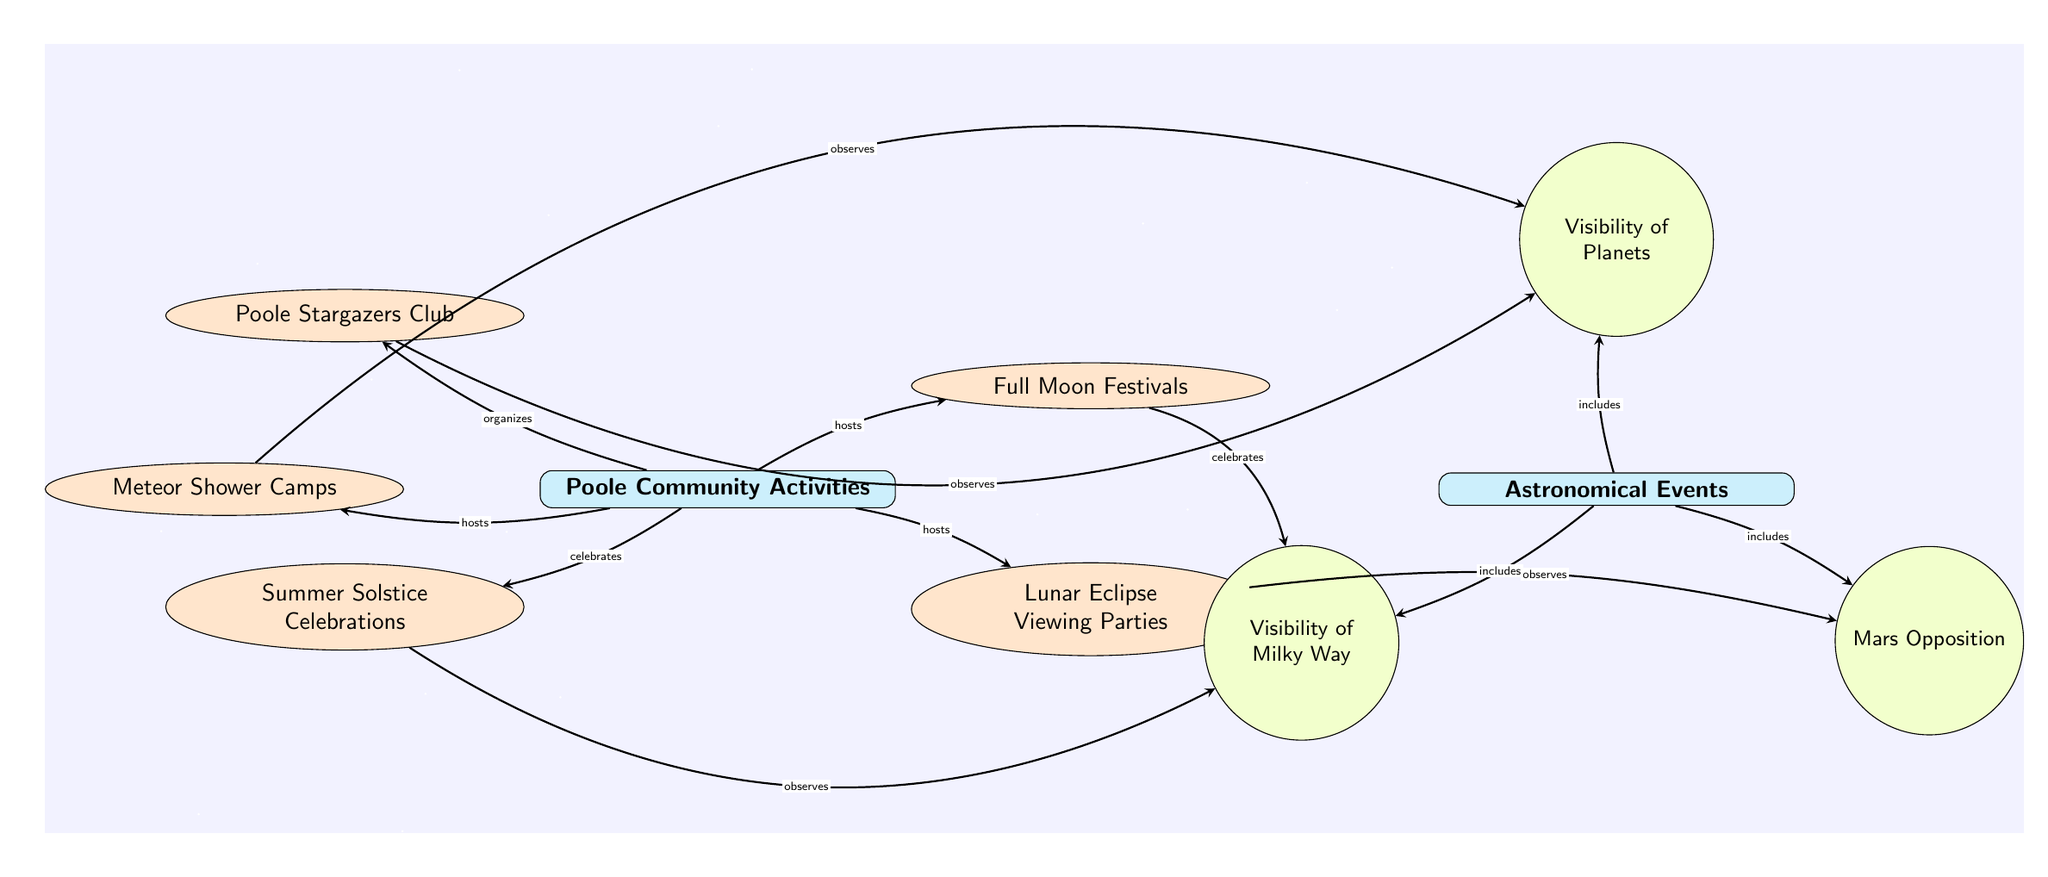What community activity is associated with the visibility of planets? The diagram shows that the Poole Stargazers Club observes the visibility of planets. There is a direct connection indicating this relationship.
Answer: Poole Stargazers Club How many astronomical phenomena are included in the diagram? The diagram lists three astronomical phenomena: Visibility of Planets, Mars Opposition, and Visibility of Milky Way. Counting the circles labeled as phenomena gives the total number.
Answer: 3 Which community activity celebrates the Milky Way? According to the diagram, the Full Moon Festivals celebrate the visibility of the Milky Way. There is a labeled connection from this activity to the phenomenon.
Answer: Full Moon Festivals What type of relationship exists between the Lunar Eclipse Viewing Parties and Mars Opposition? The diagram indicates that the Lunar Eclipse Viewing Parties observe the Mars Opposition. This shows a direct observational relationship from one activity to the phenomenon.
Answer: observes Which activity is organized AND hosted by the Poole community? The diagram shows that the community organizes the Poole Stargazers Club and hosts both Full Moon Festivals and Lunar Eclipse Viewing Parties. However, no activity fulfills both roles simultaneously; hence, more than one is needed to answer. The answer is that the Poole community does organization to the Stargazers and hosting of others.
Answer: Poole Stargazers Club, Full Moon Festivals, Lunar Eclipse Viewing Parties 